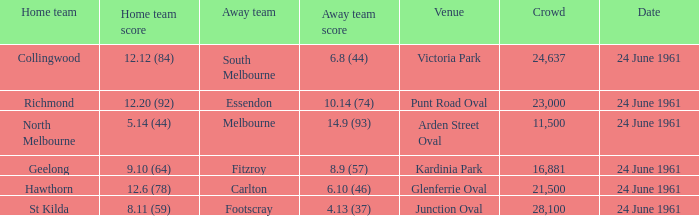What is the date of the game where the home team scored 9.10 (64)? 24 June 1961. 